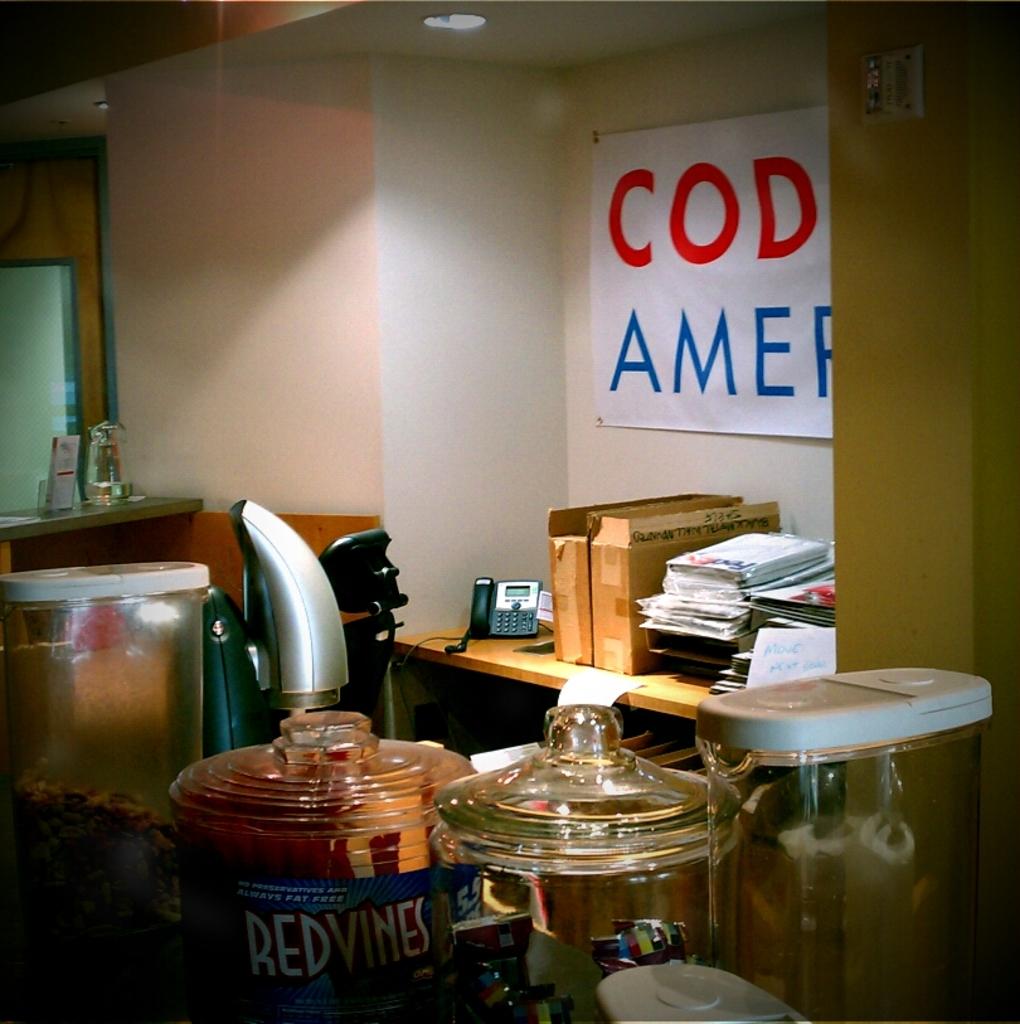What letters are written in red?
Your response must be concise. Cod. 